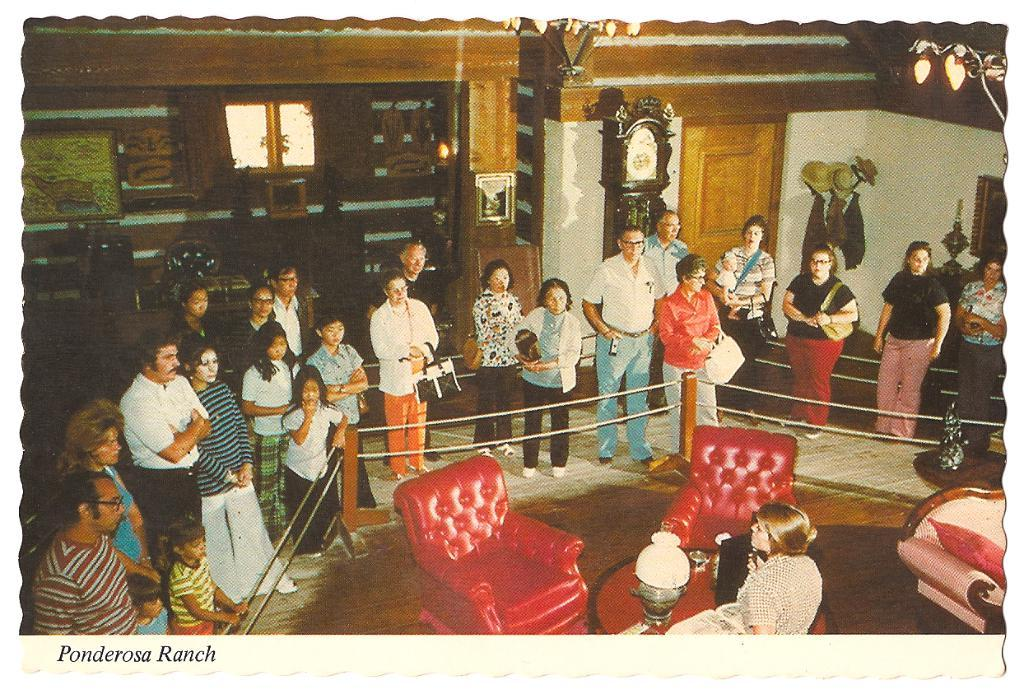<image>
Present a compact description of the photo's key features. A picture of many people with the label Ponderosa Ranch. 